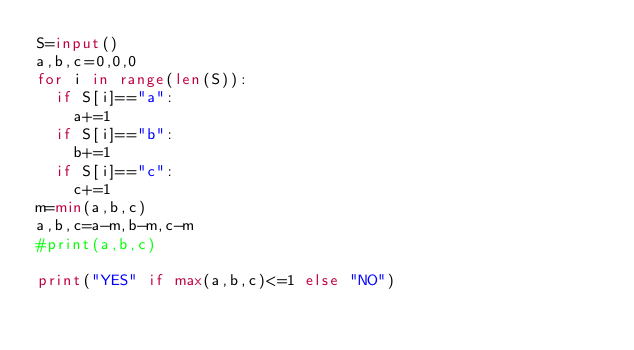<code> <loc_0><loc_0><loc_500><loc_500><_Python_>S=input()
a,b,c=0,0,0
for i in range(len(S)):
  if S[i]=="a":
    a+=1
  if S[i]=="b":
    b+=1
  if S[i]=="c":
    c+=1
m=min(a,b,c)
a,b,c=a-m,b-m,c-m
#print(a,b,c)

print("YES" if max(a,b,c)<=1 else "NO")</code> 